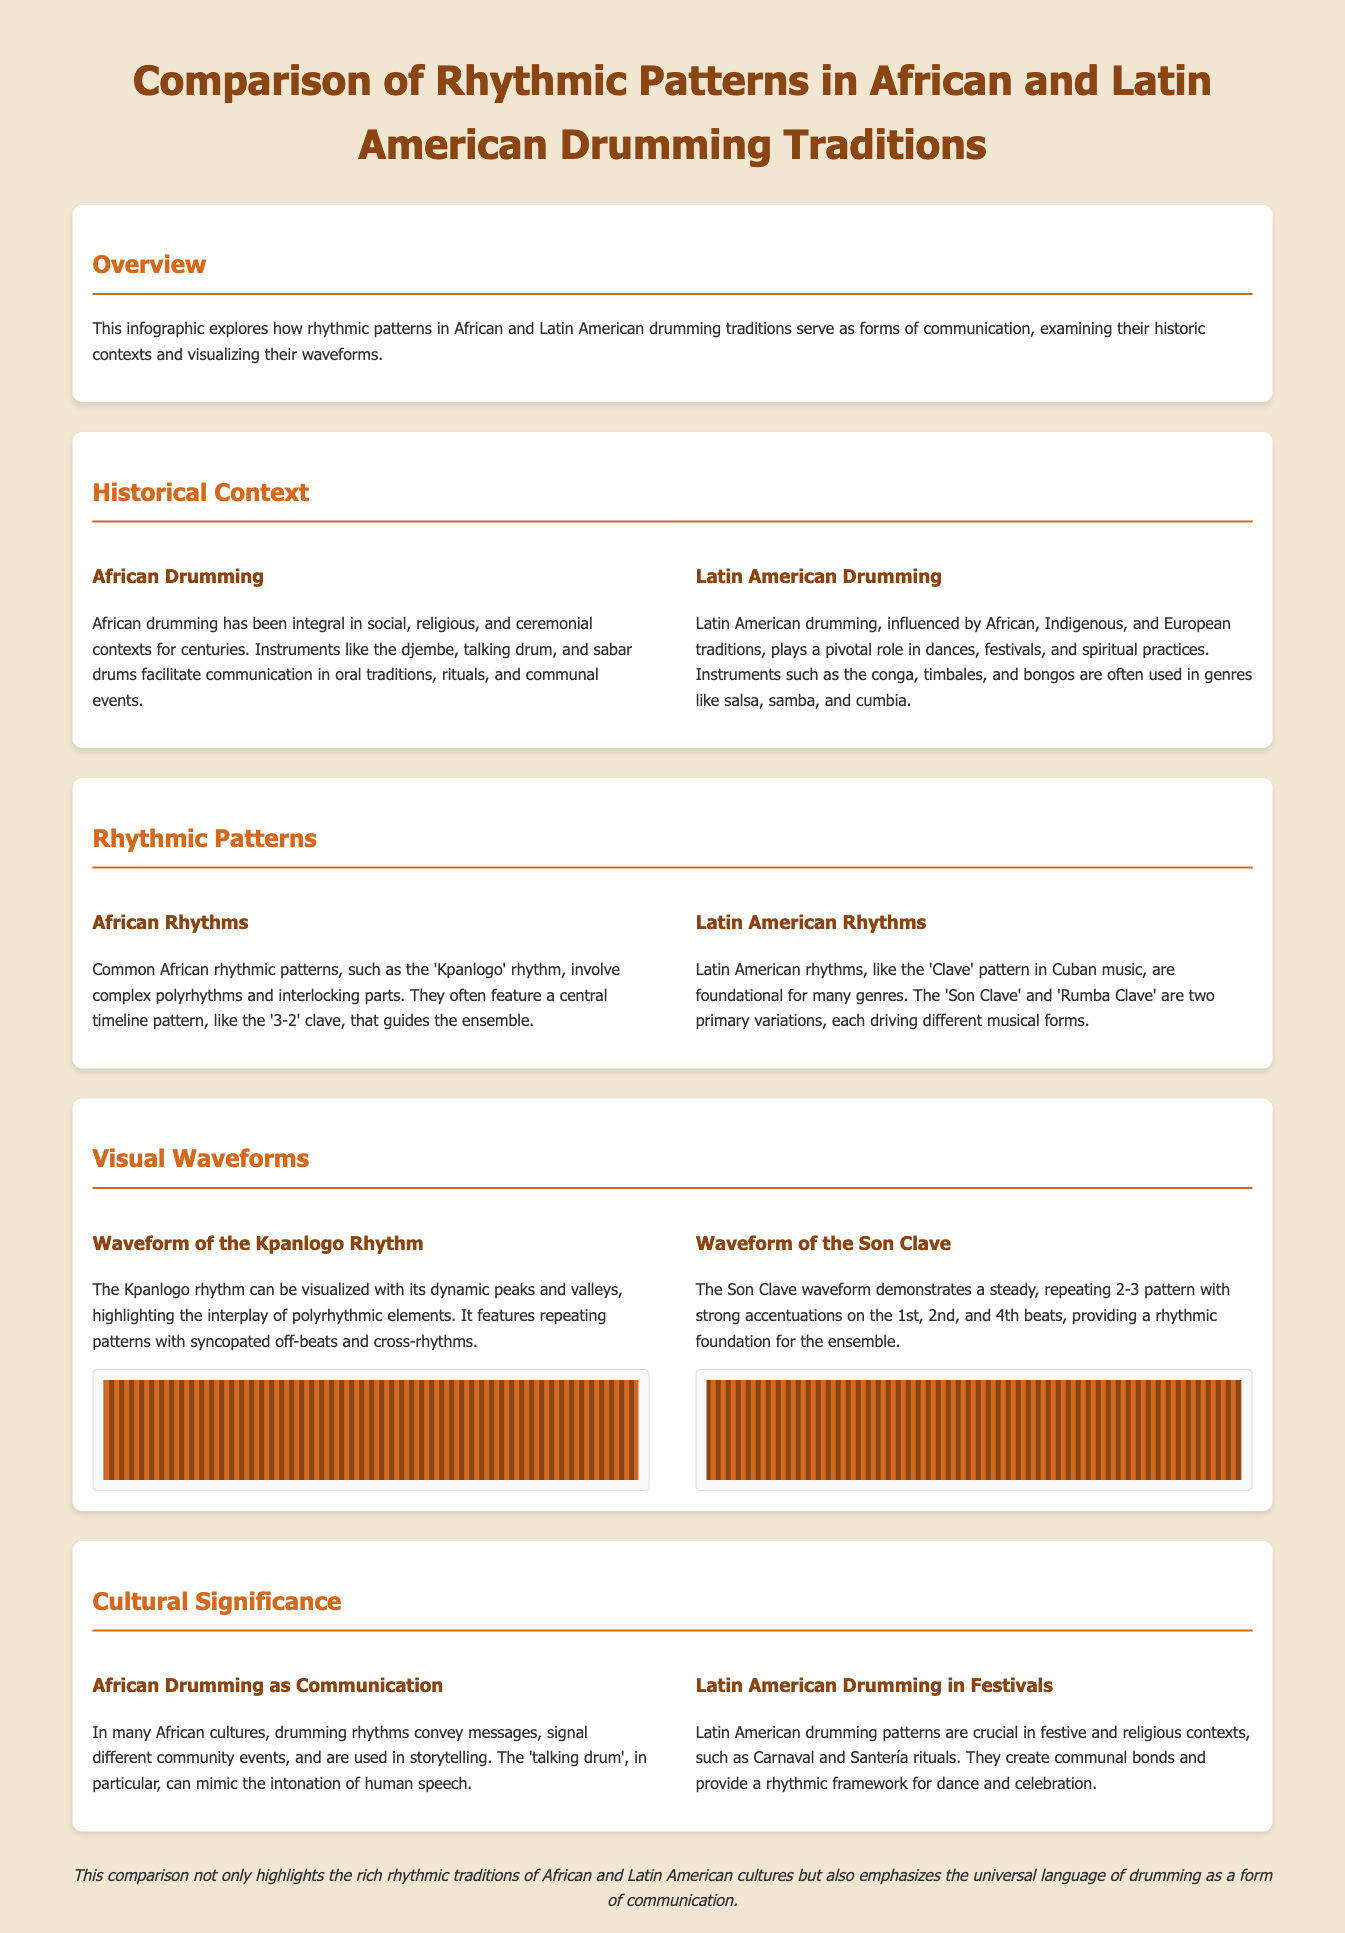What is the main focus of the infographic? The infographic explores rhythmic patterns in drumming traditions as forms of communication, historical contexts, and visual waveforms.
Answer: Rhythmic patterns in drumming What instrument is mentioned as a central element in African drumming? The infographic highlights specific instruments such as the djembe, talking drum, and sabar drums in relation to African drumming.
Answer: Djembe Which rhythmic pattern is foundational in Cuban music? The document details the 'Clave' pattern as a foundational rhythm for Cuban music, including its variations like 'Son Clave' and 'Rumba Clave'.
Answer: Clave What is the waveform of the Kpanlogo rhythm characterized by? The description of the Kpanlogo waveform emphasizes its dynamic peaks and valleys, showcasing the complexity of polyrhythms.
Answer: Dynamic peaks and valleys How do African rhythms differ from Latin American rhythms? The infographic contrasts African rhythms' complex polyrhythms and interlocking parts with Latin American rhythms' steady, repeating patterns.
Answer: Complex vs. steady patterns What significant role do Latin American drumming patterns play? The infographic states that Latin American drumming patterns are crucial in festive contexts, such as Carnaval and Santería rituals, highlighting their community-building function.
Answer: Community bonds What type of communication does the talking drum mimic? The talking drum in African culture is known for its ability to mimic the intonation of human speech, thus serving as a unique form of communication.
Answer: Human speech Which rhythmic pattern is primarily used in salsa, samba, and cumbia? The infographic notes that instruments like the conga, timbales, and bongos are used in genres such as salsa, samba, and cumbia, which are highlighted in connection with Latin American drumming.
Answer: Conga How does the infographic visually represent the rhythmic patterns? The document uses visual waveforms to illustrate the dynamic characteristics of the Kpanlogo and Son Clave rhythms.
Answer: Visual waveforms 